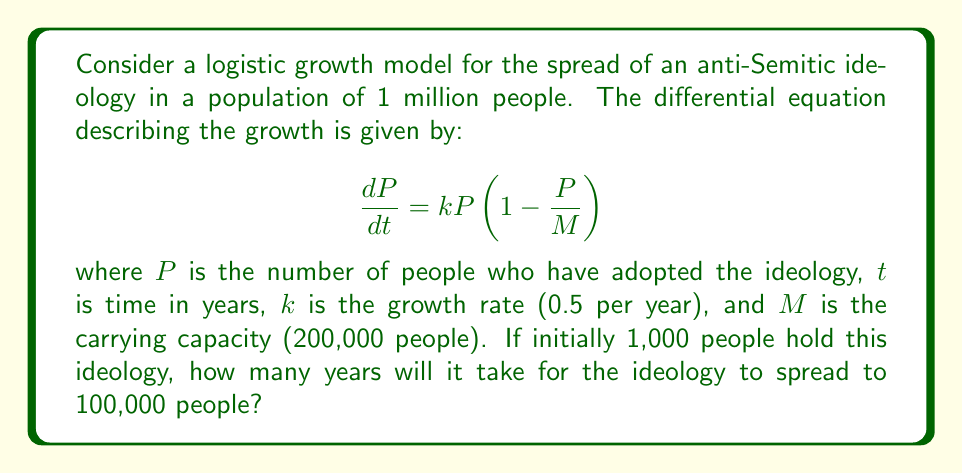Give your solution to this math problem. To solve this problem, we'll use the logistic growth function and follow these steps:

1) The solution to the logistic differential equation is:

   $$P(t) = \frac{M}{1 + (\frac{M}{P_0} - 1)e^{-kt}}$$

   where $P_0$ is the initial population.

2) Given:
   $M = 200,000$
   $k = 0.5$
   $P_0 = 1,000$
   $P(t) = 100,000$ (the target population)

3) Substitute these values into the equation:

   $$100,000 = \frac{200,000}{1 + (\frac{200,000}{1,000} - 1)e^{-0.5t}}$$

4) Simplify:

   $$100,000 = \frac{200,000}{1 + 199e^{-0.5t}}$$

5) Multiply both sides by the denominator:

   $$100,000(1 + 199e^{-0.5t}) = 200,000$$

6) Expand:

   $$100,000 + 19,900,000e^{-0.5t} = 200,000$$

7) Subtract 100,000 from both sides:

   $$19,900,000e^{-0.5t} = 100,000$$

8) Divide both sides by 19,900,000:

   $$e^{-0.5t} = \frac{1}{199}$$

9) Take the natural log of both sides:

   $$-0.5t = \ln(\frac{1}{199}) = -\ln(199)$$

10) Solve for t:

    $$t = \frac{\ln(199)}{0.5} \approx 10.58$$

Therefore, it will take approximately 10.58 years for the ideology to spread to 100,000 people.
Answer: $10.58$ years 